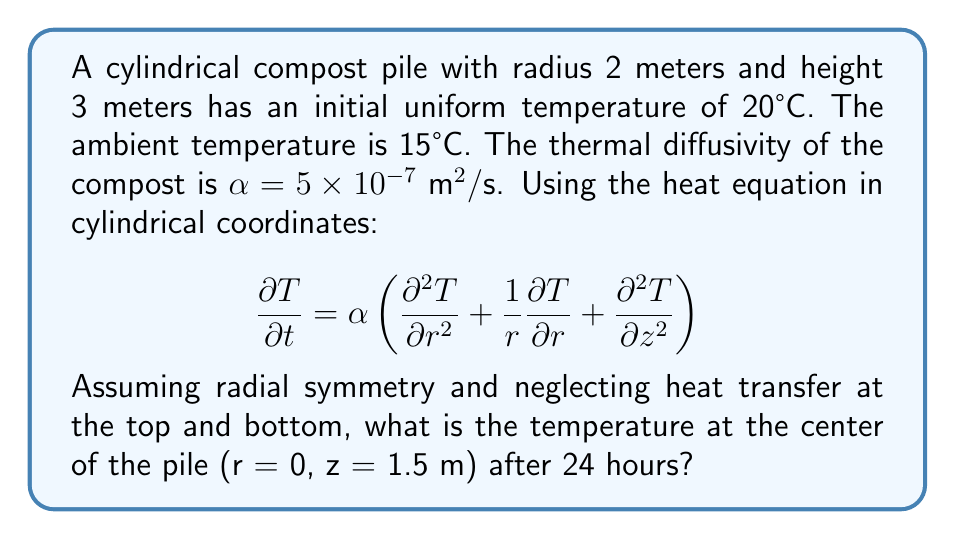Could you help me with this problem? To solve this problem, we'll use the separation of variables method:

1) Assume the solution has the form: $T(r,z,t) = R(r)Z(z)e^{-\lambda^2 \alpha t}$

2) Substituting into the heat equation and separating variables:

   $$\frac{1}{R}\frac{d^2R}{dr^2} + \frac{1}{rR}\frac{dR}{dr} + \frac{1}{Z}\frac{d^2Z}{dz^2} = -\lambda^2$$

3) This leads to two ordinary differential equations:

   $$\frac{d^2R}{dr^2} + \frac{1}{r}\frac{dR}{dr} + \beta^2R = 0$$
   $$\frac{d^2Z}{dz^2} + \gamma^2Z = 0$$

   where $\beta^2 + \gamma^2 = \lambda^2$

4) The solution for R(r) is a Bessel function of the first kind: $R(r) = J_0(\beta r)$

5) The boundary condition $T(2,z,t) = 15$ implies $J_0(2\beta) = 0$

6) The smallest positive root of this equation is $\beta_1 \approx 1.2024$

7) The solution for Z(z) is $Z(z) = \cos(\gamma z)$, where $\gamma = 0$ due to the insulated top and bottom

8) The complete solution is:

   $$T(r,z,t) = 15 + (20-15)J_0(\beta_1 r)e^{-\beta_1^2 \alpha t}$$

9) At the center (r = 0, z = 1.5 m) after 24 hours (t = 86400 s):

   $$T(0,1.5,86400) = 15 + 5J_0(0)e^{-1.2024^2 \times 5 \times 10^{-7} \times 86400}$$

10) Calculating:
    $$T(0,1.5,86400) = 15 + 5 \times 1 \times e^{-62.33} \approx 15.0000216°C$$
Answer: 15.0000216°C 